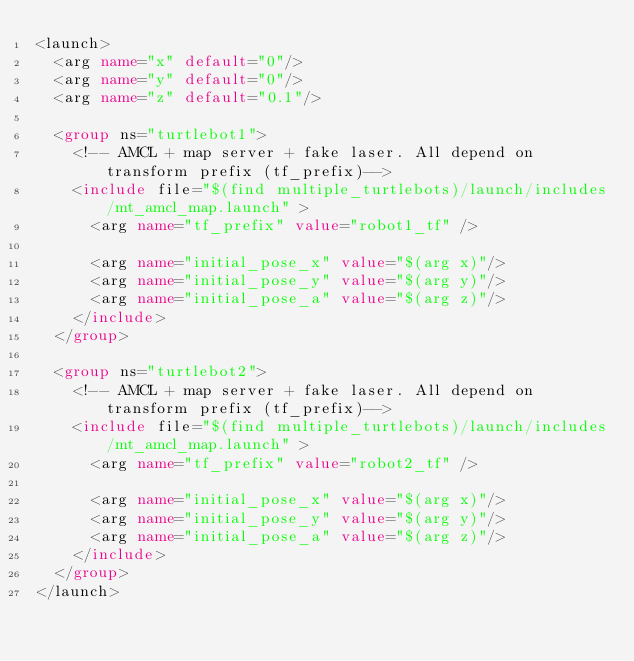<code> <loc_0><loc_0><loc_500><loc_500><_XML_><launch>
  <arg name="x" default="0"/>
  <arg name="y" default="0"/>
  <arg name="z" default="0.1"/>

  <group ns="turtlebot1">
    <!-- AMCL + map server + fake laser. All depend on transform prefix (tf_prefix)-->
    <include file="$(find multiple_turtlebots)/launch/includes/mt_amcl_map.launch" >
      <arg name="tf_prefix" value="robot1_tf" />

      <arg name="initial_pose_x" value="$(arg x)"/>
      <arg name="initial_pose_y" value="$(arg y)"/>
      <arg name="initial_pose_a" value="$(arg z)"/>
    </include>
  </group>

  <group ns="turtlebot2">
    <!-- AMCL + map server + fake laser. All depend on transform prefix (tf_prefix)-->
    <include file="$(find multiple_turtlebots)/launch/includes/mt_amcl_map.launch" >
      <arg name="tf_prefix" value="robot2_tf" />

      <arg name="initial_pose_x" value="$(arg x)"/>
      <arg name="initial_pose_y" value="$(arg y)"/>
      <arg name="initial_pose_a" value="$(arg z)"/>
    </include>
  </group>
</launch>
</code> 